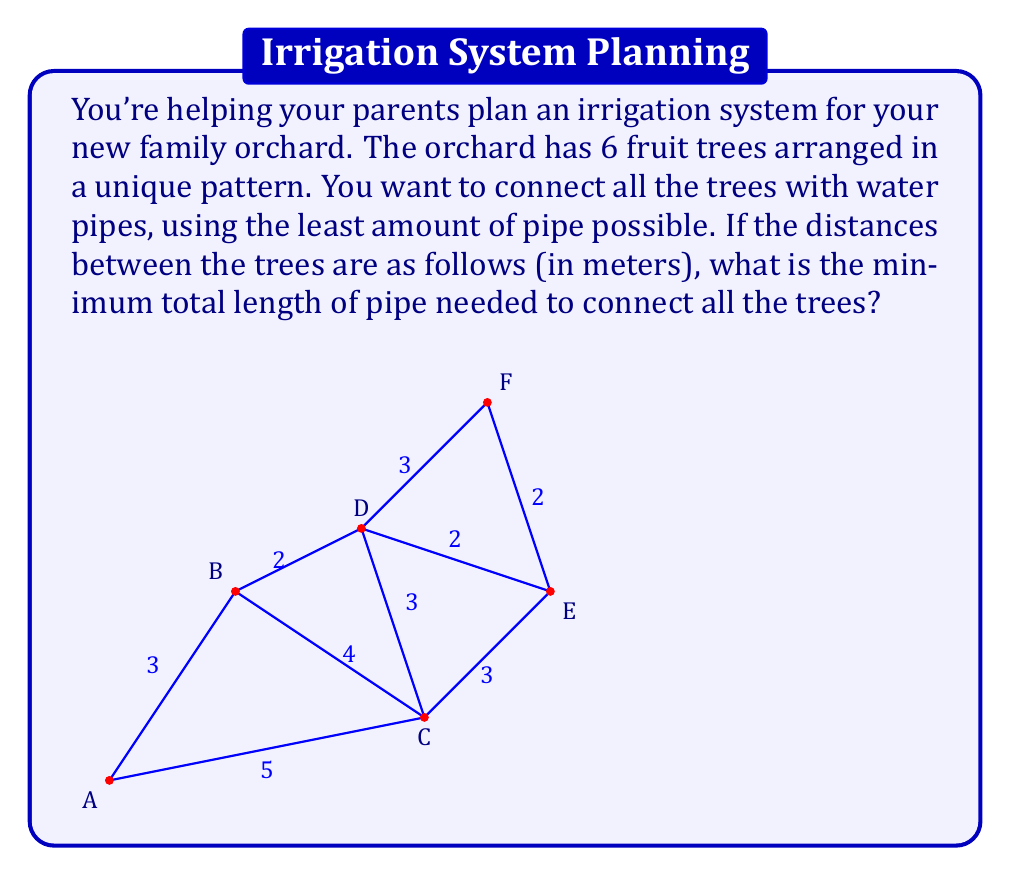Show me your answer to this math problem. This problem is a perfect application of the Minimum Spanning Tree (MST) in graph theory. Here's how we can solve it:

1) First, we recognize that the trees and the pipes form a graph, where the trees are vertices and the pipes are edges.

2) Our goal is to find the minimum spanning tree of this graph, which will give us the minimum total length of pipe needed to connect all trees.

3) We can use Kruskal's algorithm to find the MST:
   
   a) Sort all edges by weight (length) in ascending order:
      BD: 2, DE: 2, EF: 2, AB: 3, CD: 3, CE: 3, DF: 3, BC: 4, AC: 5

   b) Start with an empty set of edges and add edges one by one, smallest first, as long as they don't create a cycle:
      
      - Add BD (2)
      - Add DE (2)
      - Add EF (2)
      - Add AB (3)
      - Add CD (3)

4) After these steps, all 6 vertices are connected with 5 edges, which is the minimum number needed for a tree.

5) The total length of the MST is the sum of these edge weights:
   $$ 2 + 2 + 2 + 3 + 3 = 12 $$

Therefore, the minimum total length of pipe needed is 12 meters.
Answer: 12 meters 